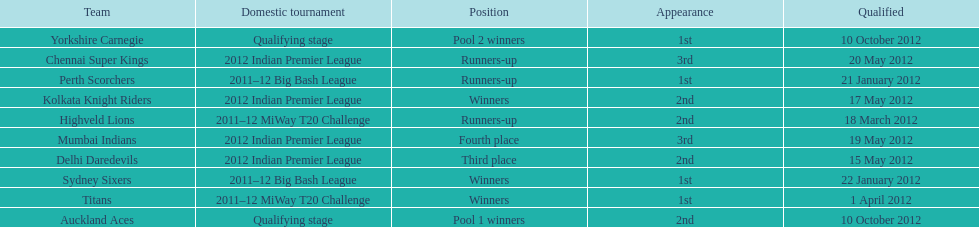Which team came in after the titans in the miway t20 challenge? Highveld Lions. 